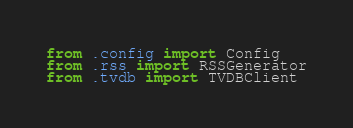<code> <loc_0><loc_0><loc_500><loc_500><_Python_>from .config import Config
from .rss import RSSGenerator
from .tvdb import TVDBClient
</code> 